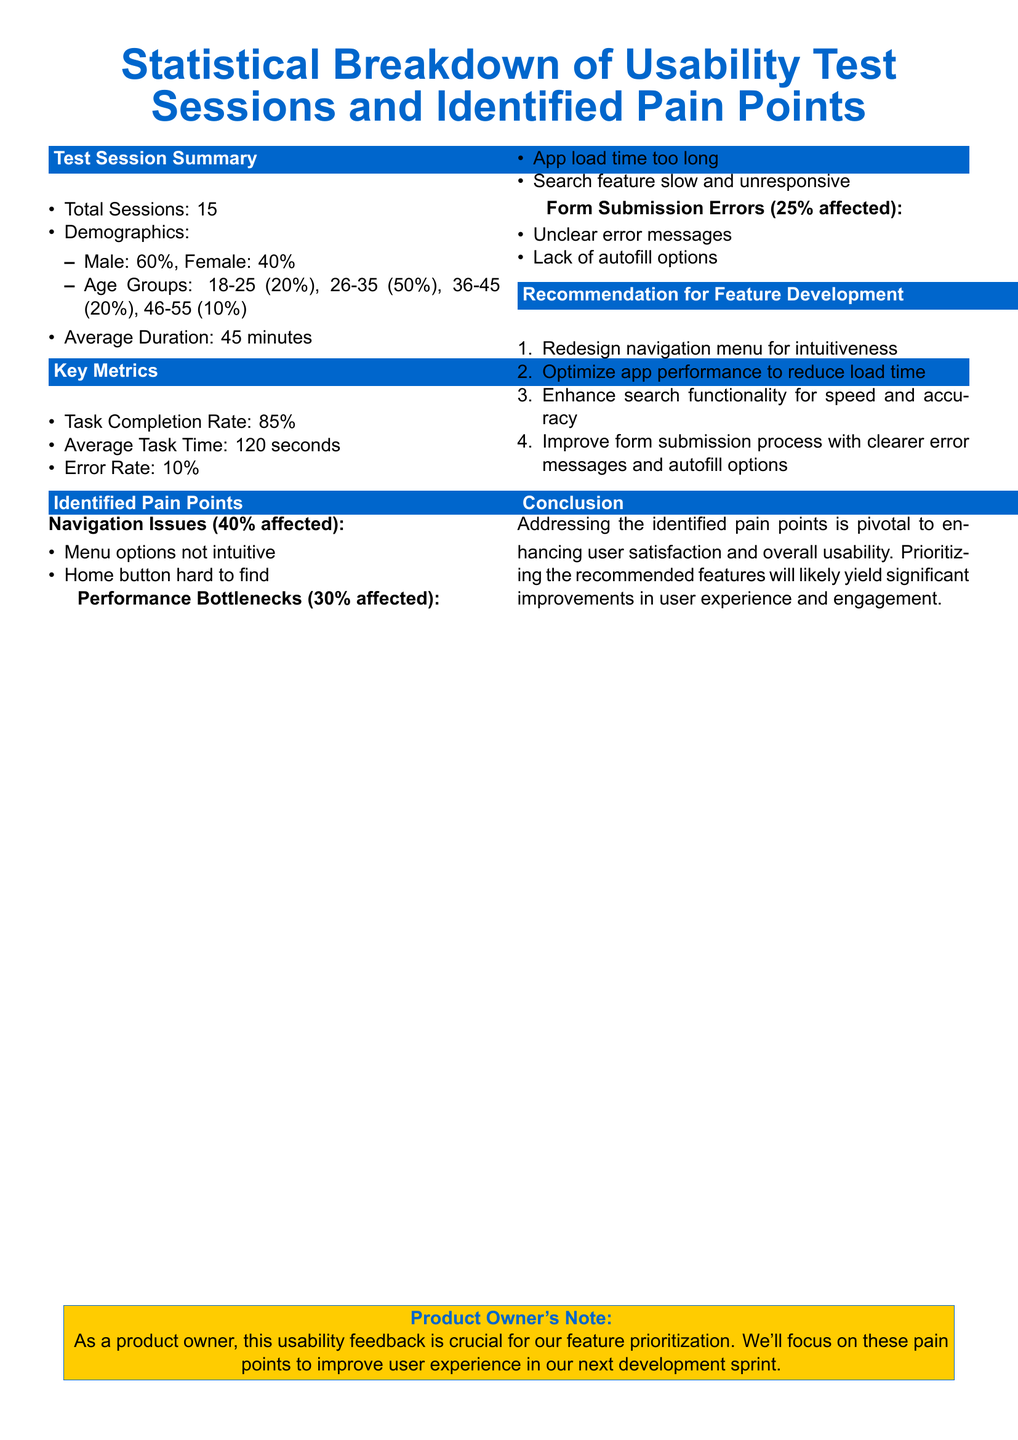What is the total number of sessions conducted? The total sessions are summarized in the document, which indicates there were 15 usability test sessions held.
Answer: 15 What percentage of participants were female? The demographic breakdown shows that 40% of the participants were female.
Answer: 40% What is the average task completion rate? The average task completion rate is provided in the key metrics section of the report, listed as 85%.
Answer: 85% What are the two main identified pain points related to navigation? Navigation issues are detailed as menu options not being intuitive and the home button being hard to find.
Answer: Menu options not intuitive, Home button hard to find What recommendation is suggested to enhance search functionality? The recommendation section specifies to improve search functionality for speed and accuracy as a key development focus.
Answer: Enhance search functionality for speed and accuracy How long is the average duration of the sessions? The average duration of the sessions is explicitly mentioned in the document, showing it as 45 minutes.
Answer: 45 minutes What is the percentage of participants affected by performance bottlenecks? Performance bottlenecks impacted 30% of the study participants, according to the identified pain points section.
Answer: 30% What type of error messages are noted in the form submission issues? The document identifies the error messages as being unclear in terms of user guidance during form submissions.
Answer: Unclear error messages What is a key product owner’s note from the conclusion? The product owner's note emphasizes the importance of usability feedback for prioritizing features and enhancing user experience.
Answer: Crucial for feature prioritization 